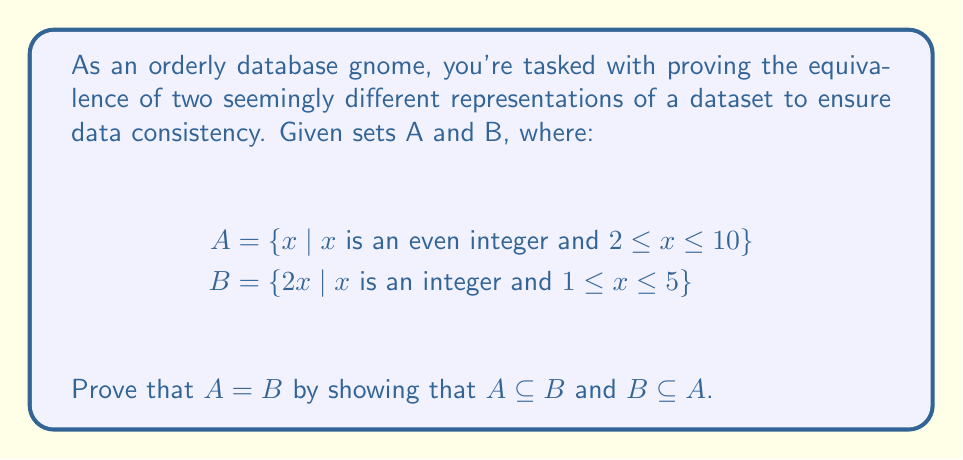What is the answer to this math problem? To prove that A = B, we need to show that every element in A is also in B (A ⊆ B) and every element in B is also in A (B ⊆ A). Let's approach this step-by-step:

1. Prove A ⊆ B:
   Let x be an arbitrary element of A.
   By the definition of A, x is an even integer and 2 ≤ x ≤ 10.
   Since x is even, we can express it as x = 2k, where k is an integer.
   Given the range of x, we know that 1 ≤ k ≤ 5.
   This means x can be written as 2k where k is an integer and 1 ≤ k ≤ 5.
   This matches the definition of B exactly.
   Therefore, x ∈ B, and we have shown that A ⊆ B.

2. Prove B ⊆ A:
   Let y be an arbitrary element of B.
   By the definition of B, y = 2x where x is an integer and 1 ≤ x ≤ 5.
   This means y is even (since it's a multiple of 2) and 2 ≤ y ≤ 10.
   This matches the definition of A exactly.
   Therefore, y ∈ A, and we have shown that B ⊆ A.

Since we have proven both A ⊆ B and B ⊆ A, we can conclude that A = B.

To list out the elements explicitly:
A = {2, 4, 6, 8, 10}
B = {2(1), 2(2), 2(3), 2(4), 2(5)} = {2, 4, 6, 8, 10}

This confirms our proof that A and B are indeed equivalent representations of the same set.
Answer: A = B, as proven by showing A ⊆ B and B ⊆ A. Both sets represent {2, 4, 6, 8, 10}. 